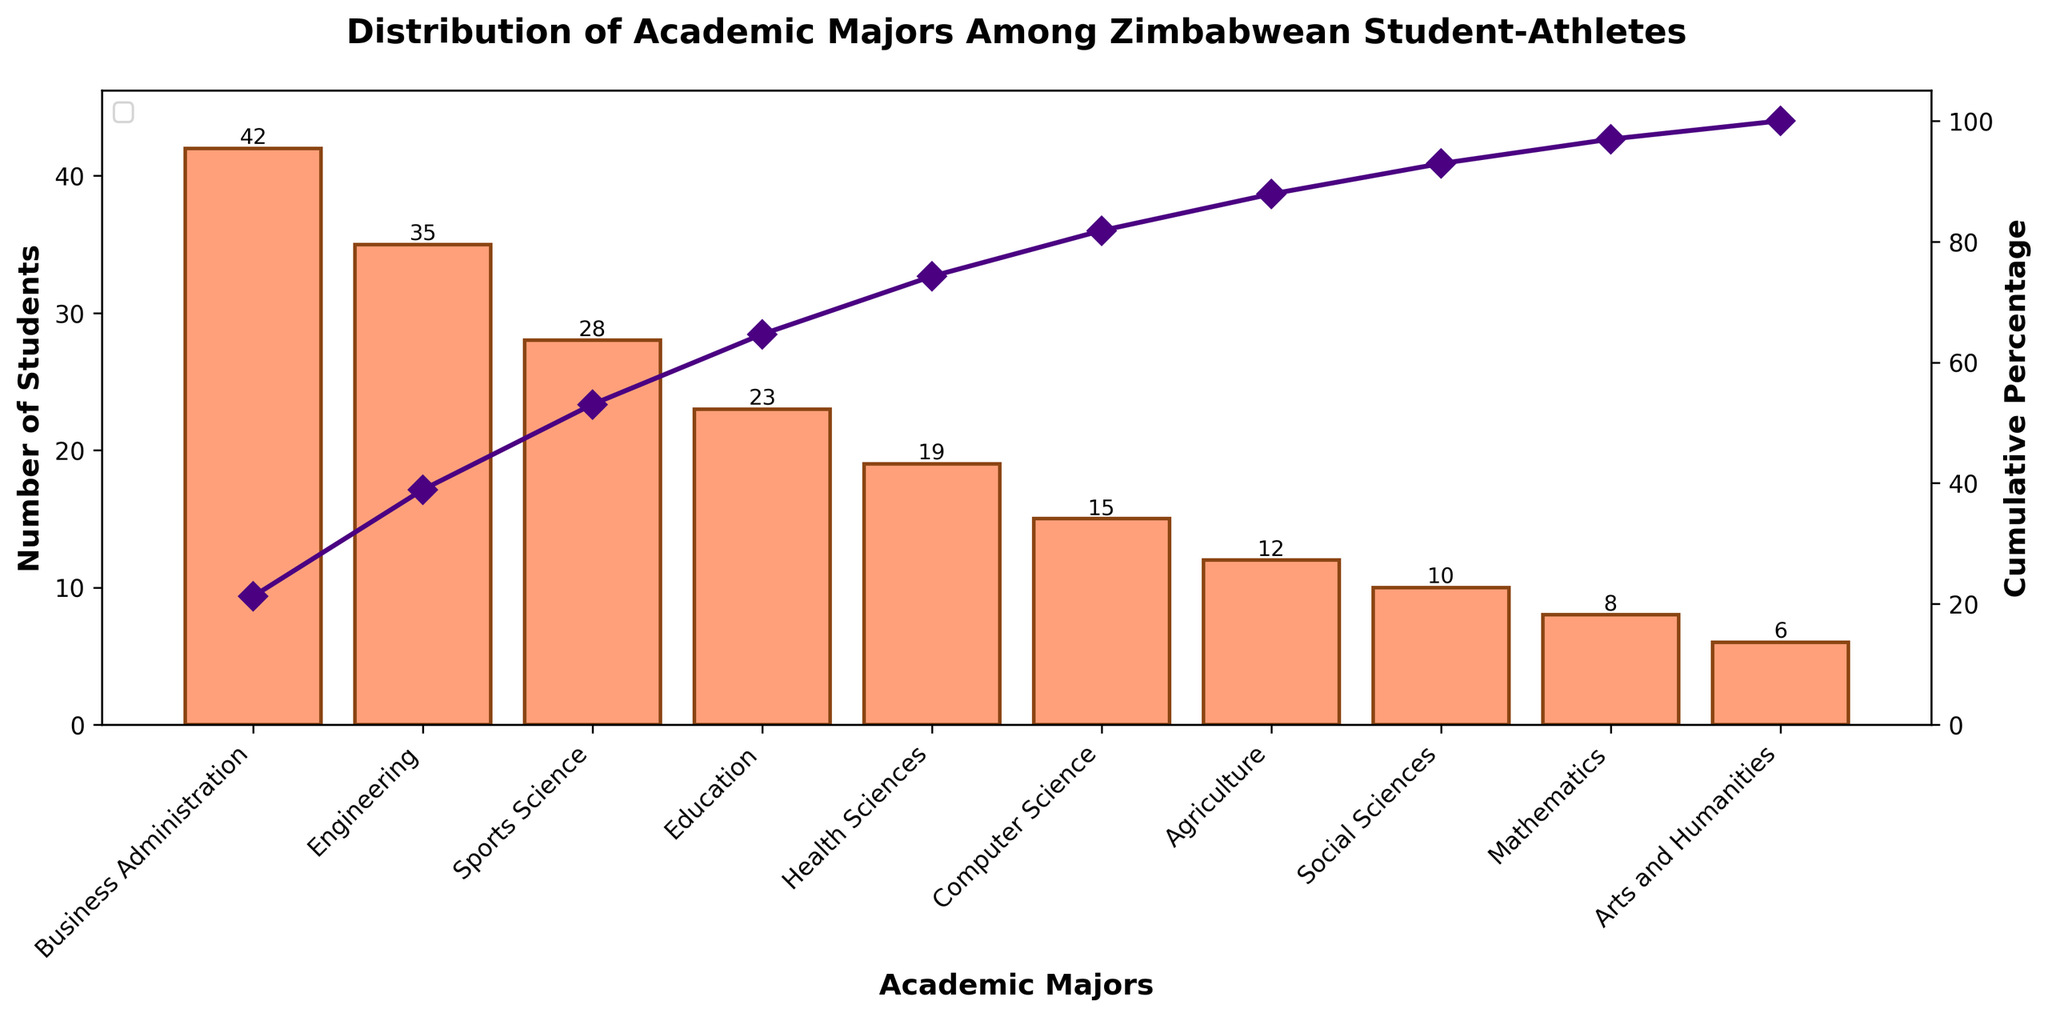What is the title of the plot? The title of the plot is displayed at the top center of the figure and it summarizes the content of the plot. The title is "Distribution of Academic Majors Among Zimbabwean Student-Athletes".
Answer: Distribution of Academic Majors Among Zimbabwean Student-Athletes Which major has the highest number of students? To find the major with the highest number of students, look at the bars in the bar chart and find the one with the greatest height. The major with the highest number of students is "Business Administration".
Answer: Business Administration What is the cumulative percentage for the Health Sciences major? To find the cumulative percentage for the Health Sciences major, look for its position on the x-axis and find the corresponding point on the cumulative percentage line. The cumulative percentage for Health Sciences is 78%.
Answer: 78% How many majors have more than 20 students? To answer this, count the number of bars that have a height greater than 20. The majors that have more than 20 students are Business Administration (42), Engineering (35), Sports Science (28), and Education (23), so there are 4 majors.
Answer: 4 Which major has the lowest number of students and what is that number? Look for the shortest bar in the bar chart to identify the major with the lowest number of students. The major is "Arts and Humanities" with 6 students.
Answer: Arts and Humanities, 6 What is the cumulative percentage after including Sports Science major? The cumulative percentage line can be followed to the point where it includes the value for Sports Science. This position shows that the cumulative percentage after including Sports Science is 63%.
Answer: 63% What is the difference in the number of students between Computer Science and Social Sciences? To find the difference, subtract the number of students in Social Sciences (10) from the number of students in Computer Science (15). The difference is 5.
Answer: 5 How many students are there in total across all majors? The total number of students is obtained by summing the number of students for all majors. Summing the numbers gives 42 + 35 + 28 + 23 + 19 + 15 + 12 + 10 + 8 + 6 = 198.
Answer: 198 Which major marks the 50% cumulative percentage point? Follow the cumulative percentage line and identify the major at the point where the line crosses the 50% mark. Sports Science is the major that marks the 50% cumulative percentage point.
Answer: Sports Science What is the total number of students in majors with fewer than 10 students? Add the number of students in all majors with fewer than 10 students: Mathematics (8) + Arts and Humanities (6) = 8 + 6 = 14.
Answer: 14 